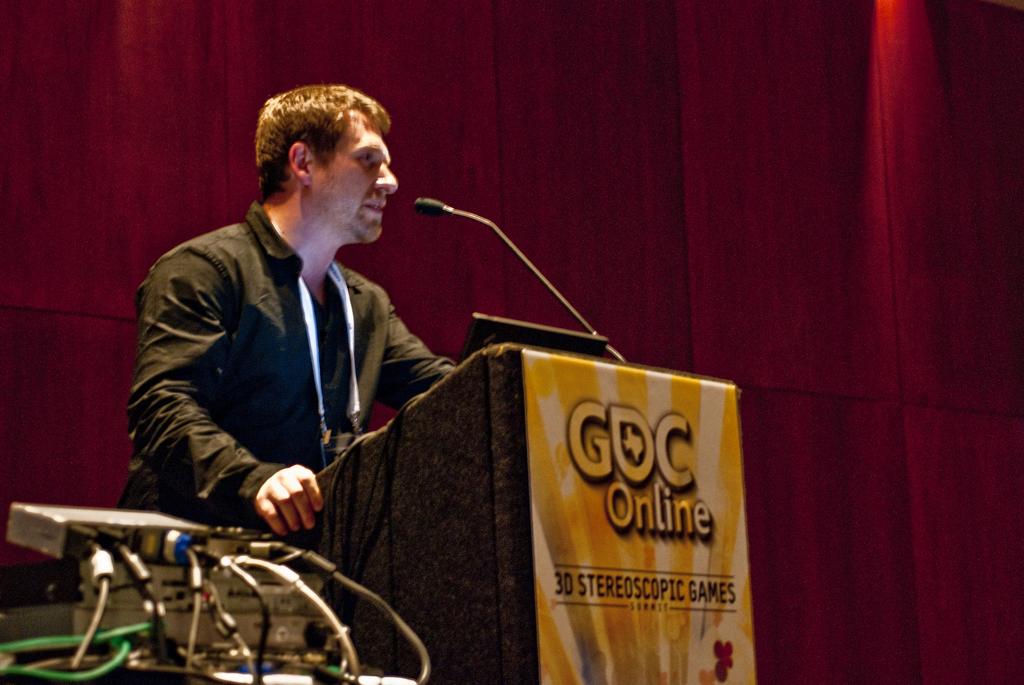What kind of games are on the front of the podium?
Keep it short and to the point. 3d stereoscopic. What is the abbreviation on the podium?
Your response must be concise. Gdc. 